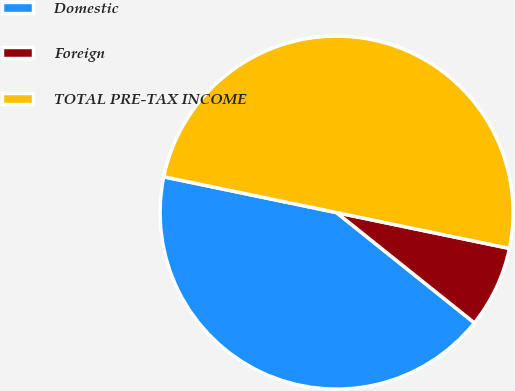Convert chart to OTSL. <chart><loc_0><loc_0><loc_500><loc_500><pie_chart><fcel>Domestic<fcel>Foreign<fcel>TOTAL PRE-TAX INCOME<nl><fcel>42.51%<fcel>7.49%<fcel>50.0%<nl></chart> 